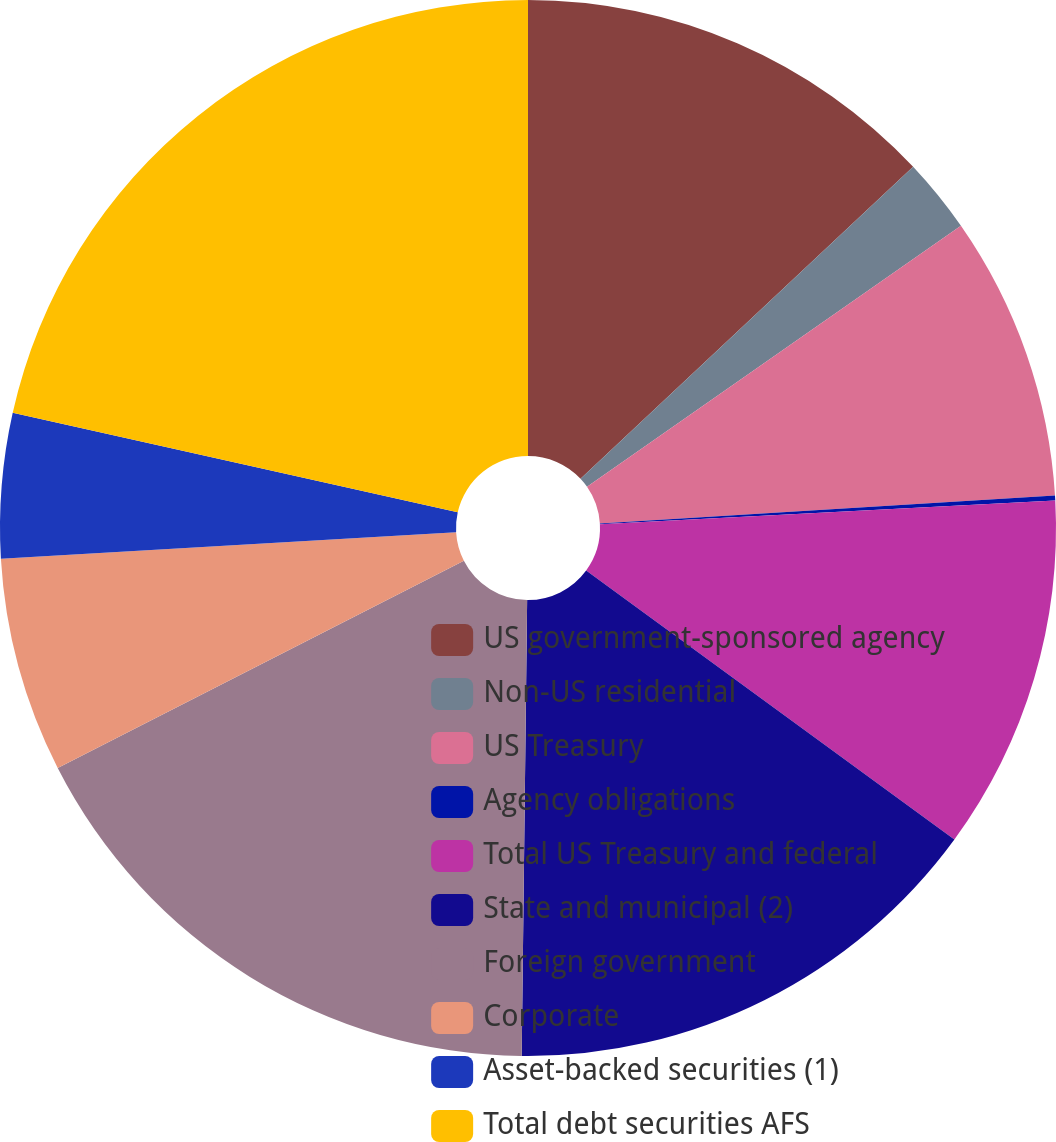<chart> <loc_0><loc_0><loc_500><loc_500><pie_chart><fcel>US government-sponsored agency<fcel>Non-US residential<fcel>US Treasury<fcel>Agency obligations<fcel>Total US Treasury and federal<fcel>State and municipal (2)<fcel>Foreign government<fcel>Corporate<fcel>Asset-backed securities (1)<fcel>Total debt securities AFS<nl><fcel>13.01%<fcel>2.29%<fcel>8.72%<fcel>0.15%<fcel>10.87%<fcel>15.15%<fcel>17.3%<fcel>6.58%<fcel>4.43%<fcel>21.5%<nl></chart> 